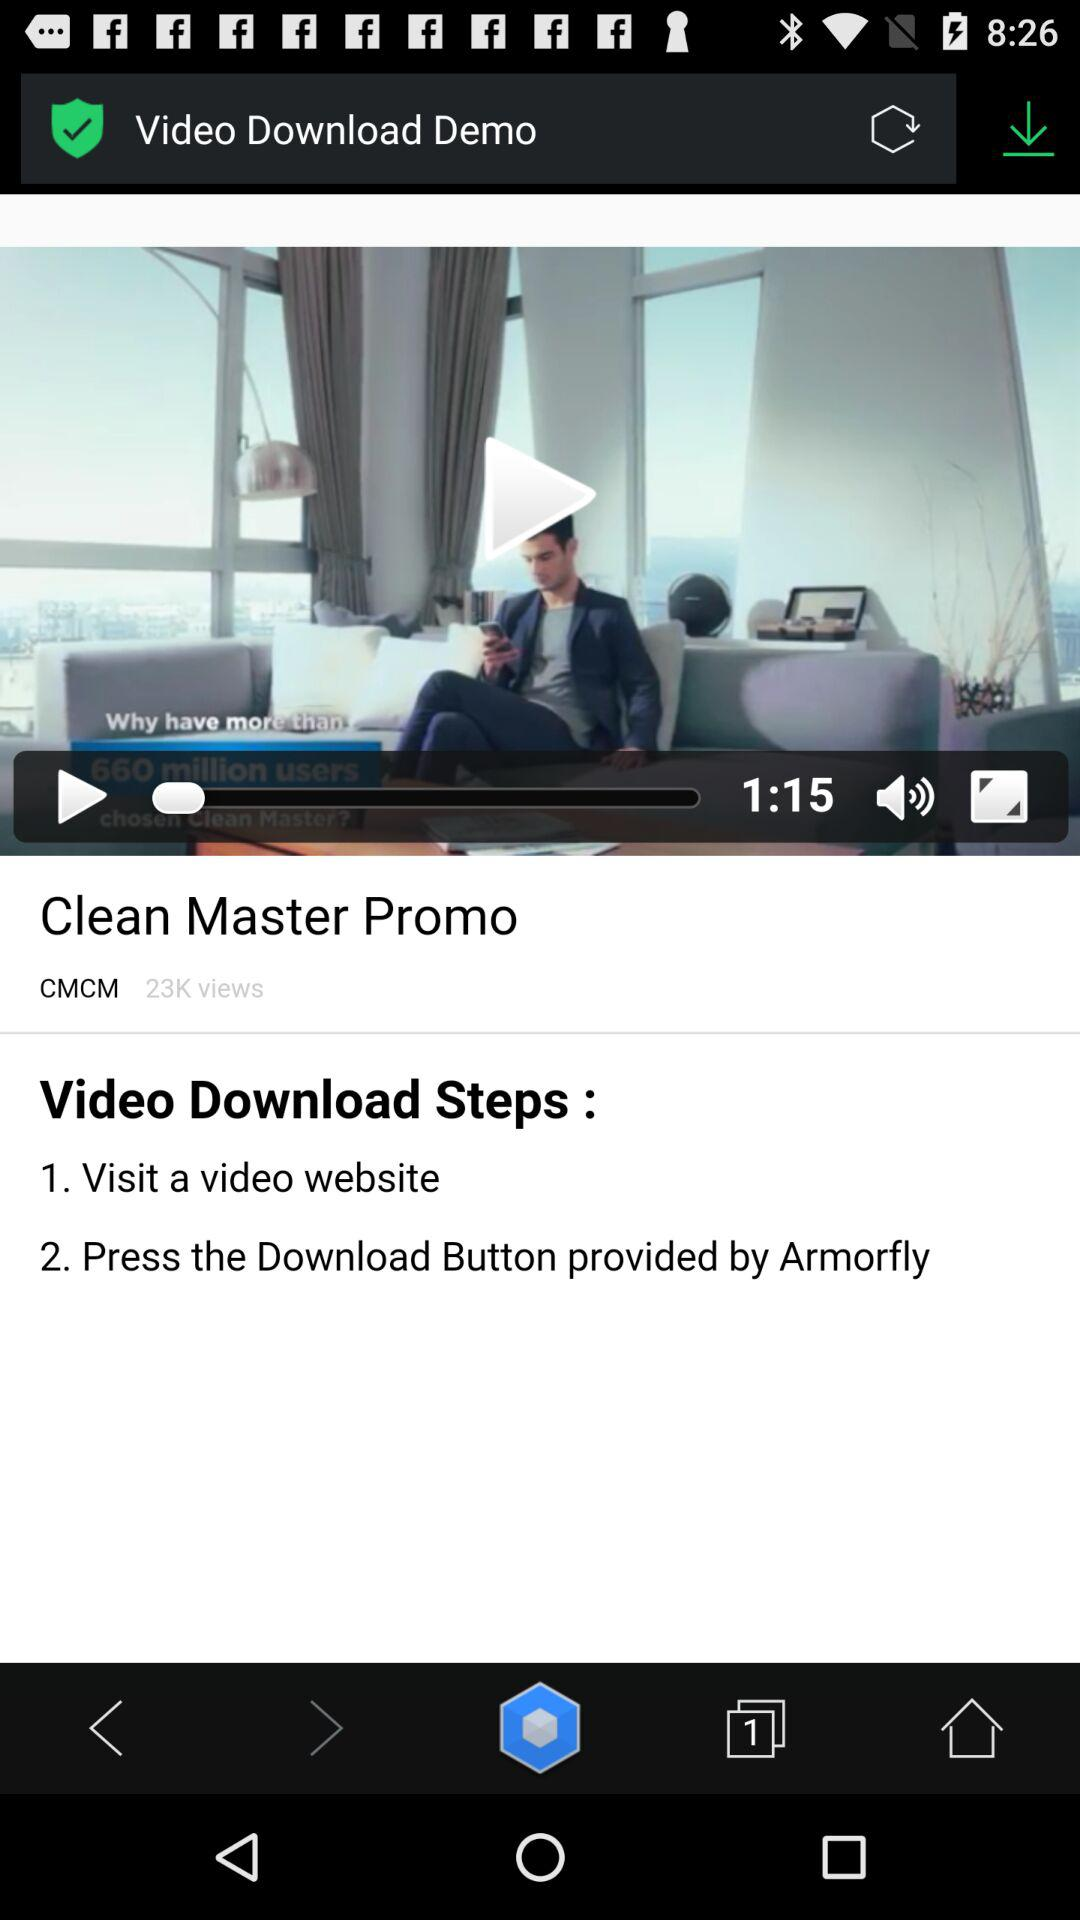What is the title of the video? The title of the video is "Clean Master Promo". 